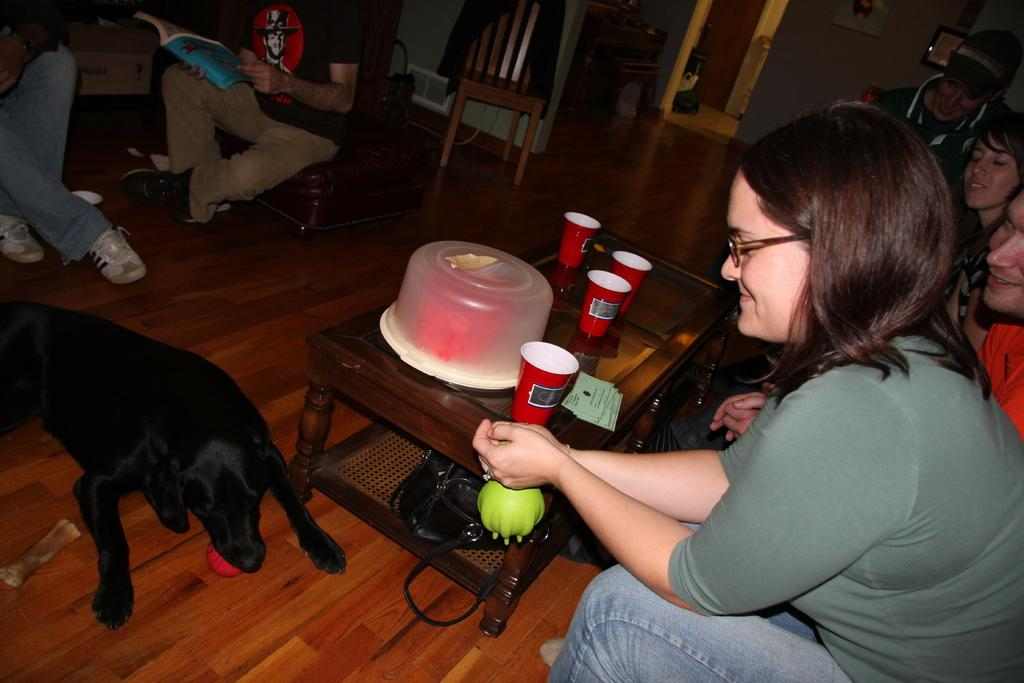What is the woman in the image doing? The woman is sitting on the sofa and looking at a dog. What objects are on the table in the image? There are glasses, a cake box, and a bag on the table. Are there any other people in the image besides the woman? Yes, there are other people in the background. What type of nail is being used to show the form of the cake in the image? There is no nail or cake being shown in the image; it features a woman sitting on a sofa looking at a dog. 